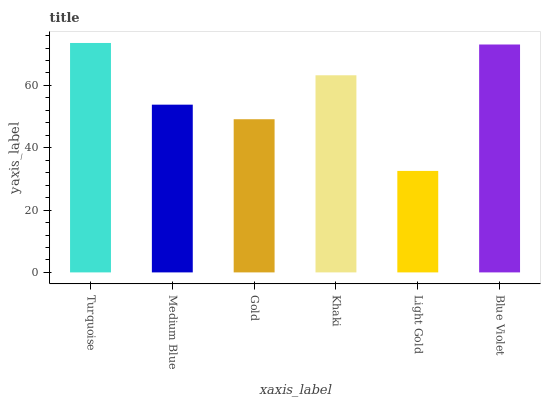Is Light Gold the minimum?
Answer yes or no. Yes. Is Turquoise the maximum?
Answer yes or no. Yes. Is Medium Blue the minimum?
Answer yes or no. No. Is Medium Blue the maximum?
Answer yes or no. No. Is Turquoise greater than Medium Blue?
Answer yes or no. Yes. Is Medium Blue less than Turquoise?
Answer yes or no. Yes. Is Medium Blue greater than Turquoise?
Answer yes or no. No. Is Turquoise less than Medium Blue?
Answer yes or no. No. Is Khaki the high median?
Answer yes or no. Yes. Is Medium Blue the low median?
Answer yes or no. Yes. Is Blue Violet the high median?
Answer yes or no. No. Is Turquoise the low median?
Answer yes or no. No. 